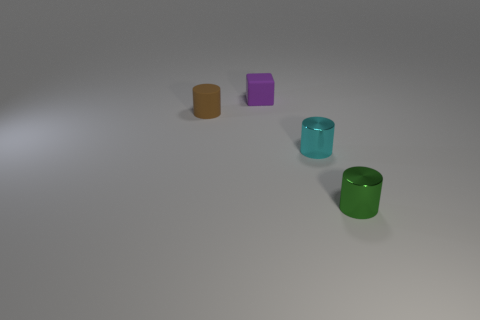There is another shiny object that is the same shape as the green metal object; what is its size?
Provide a succinct answer. Small. The small thing that is behind the small rubber cylinder has what shape?
Provide a short and direct response. Cube. What is the color of the cylinder behind the tiny metal thing that is behind the tiny green metallic thing?
Your answer should be compact. Brown. What color is the small rubber thing that is the same shape as the small cyan metallic object?
Offer a terse response. Brown. What number of rubber blocks have the same color as the small rubber cylinder?
Your response must be concise. 0. There is a object that is both to the left of the small cyan metallic cylinder and on the right side of the tiny brown matte cylinder; what is its shape?
Your answer should be very brief. Cube. There is a small cylinder that is on the left side of the shiny cylinder that is behind the cylinder that is in front of the cyan metallic cylinder; what is its material?
Ensure brevity in your answer.  Rubber. Is the number of small shiny cylinders that are left of the tiny green thing greater than the number of small green shiny objects that are behind the purple block?
Offer a very short reply. Yes. How many other cylinders have the same material as the green cylinder?
Provide a short and direct response. 1. Does the shiny thing in front of the cyan object have the same shape as the small object on the left side of the purple rubber object?
Provide a short and direct response. Yes. 